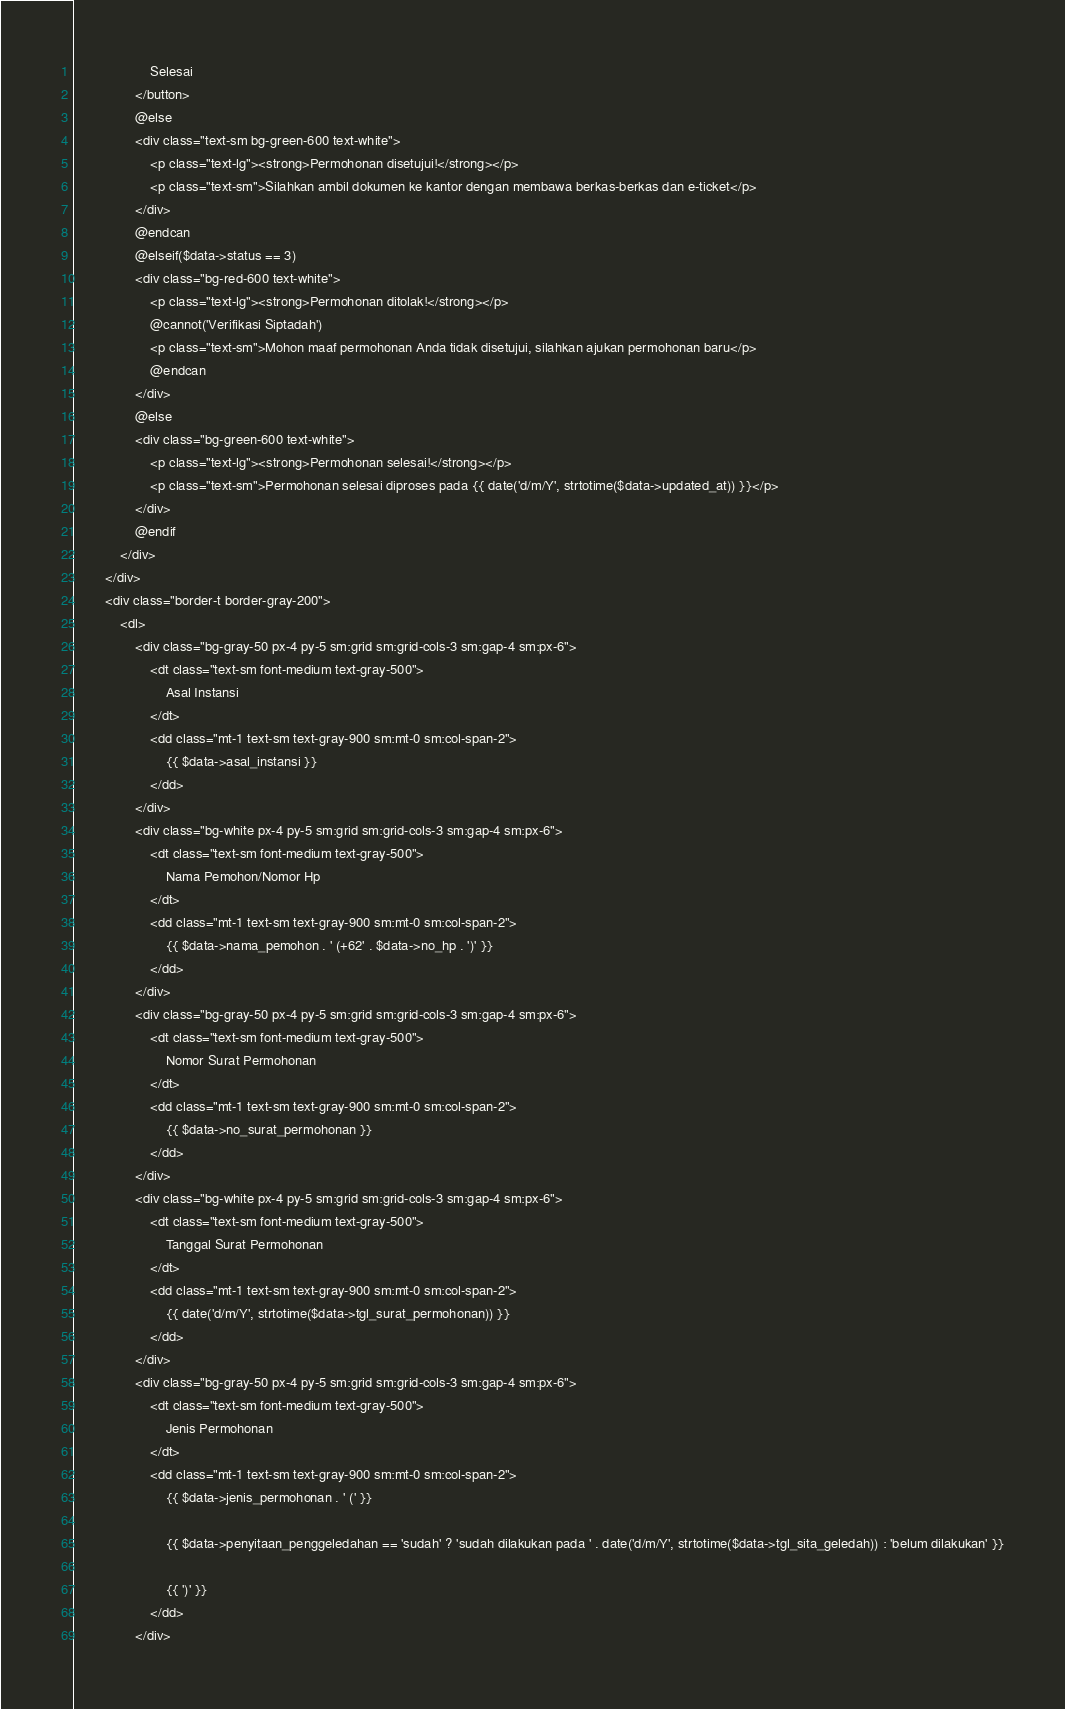<code> <loc_0><loc_0><loc_500><loc_500><_PHP_>                    Selesai
                </button>
                @else
                <div class="text-sm bg-green-600 text-white">
                    <p class="text-lg"><strong>Permohonan disetujui!</strong></p>
                    <p class="text-sm">Silahkan ambil dokumen ke kantor dengan membawa berkas-berkas dan e-ticket</p>
                </div>
                @endcan
                @elseif($data->status == 3)
                <div class="bg-red-600 text-white">
                    <p class="text-lg"><strong>Permohonan ditolak!</strong></p>
                    @cannot('Verifikasi Siptadah')
                    <p class="text-sm">Mohon maaf permohonan Anda tidak disetujui, silahkan ajukan permohonan baru</p>
                    @endcan
                </div>
                @else
                <div class="bg-green-600 text-white">
                    <p class="text-lg"><strong>Permohonan selesai!</strong></p>
                    <p class="text-sm">Permohonan selesai diproses pada {{ date('d/m/Y', strtotime($data->updated_at)) }}</p>
                </div>
                @endif
            </div>
        </div>
        <div class="border-t border-gray-200">
            <dl>
                <div class="bg-gray-50 px-4 py-5 sm:grid sm:grid-cols-3 sm:gap-4 sm:px-6">
                    <dt class="text-sm font-medium text-gray-500">
                        Asal Instansi
                    </dt>
                    <dd class="mt-1 text-sm text-gray-900 sm:mt-0 sm:col-span-2">
                        {{ $data->asal_instansi }}
                    </dd>
                </div>
                <div class="bg-white px-4 py-5 sm:grid sm:grid-cols-3 sm:gap-4 sm:px-6">
                    <dt class="text-sm font-medium text-gray-500">
                        Nama Pemohon/Nomor Hp
                    </dt>
                    <dd class="mt-1 text-sm text-gray-900 sm:mt-0 sm:col-span-2">
                        {{ $data->nama_pemohon . ' (+62' . $data->no_hp . ')' }}
                    </dd>
                </div>
                <div class="bg-gray-50 px-4 py-5 sm:grid sm:grid-cols-3 sm:gap-4 sm:px-6">
                    <dt class="text-sm font-medium text-gray-500">
                        Nomor Surat Permohonan
                    </dt>
                    <dd class="mt-1 text-sm text-gray-900 sm:mt-0 sm:col-span-2">
                        {{ $data->no_surat_permohonan }}
                    </dd>
                </div>
                <div class="bg-white px-4 py-5 sm:grid sm:grid-cols-3 sm:gap-4 sm:px-6">
                    <dt class="text-sm font-medium text-gray-500">
                        Tanggal Surat Permohonan
                    </dt>
                    <dd class="mt-1 text-sm text-gray-900 sm:mt-0 sm:col-span-2">
                        {{ date('d/m/Y', strtotime($data->tgl_surat_permohonan)) }}
                    </dd>
                </div>
                <div class="bg-gray-50 px-4 py-5 sm:grid sm:grid-cols-3 sm:gap-4 sm:px-6">
                    <dt class="text-sm font-medium text-gray-500">
                        Jenis Permohonan
                    </dt>
                    <dd class="mt-1 text-sm text-gray-900 sm:mt-0 sm:col-span-2">
                        {{ $data->jenis_permohonan . ' (' }}

                        {{ $data->penyitaan_penggeledahan == 'sudah' ? 'sudah dilakukan pada ' . date('d/m/Y', strtotime($data->tgl_sita_geledah)) : 'belum dilakukan' }}

                        {{ ')' }}
                    </dd>
                </div></code> 